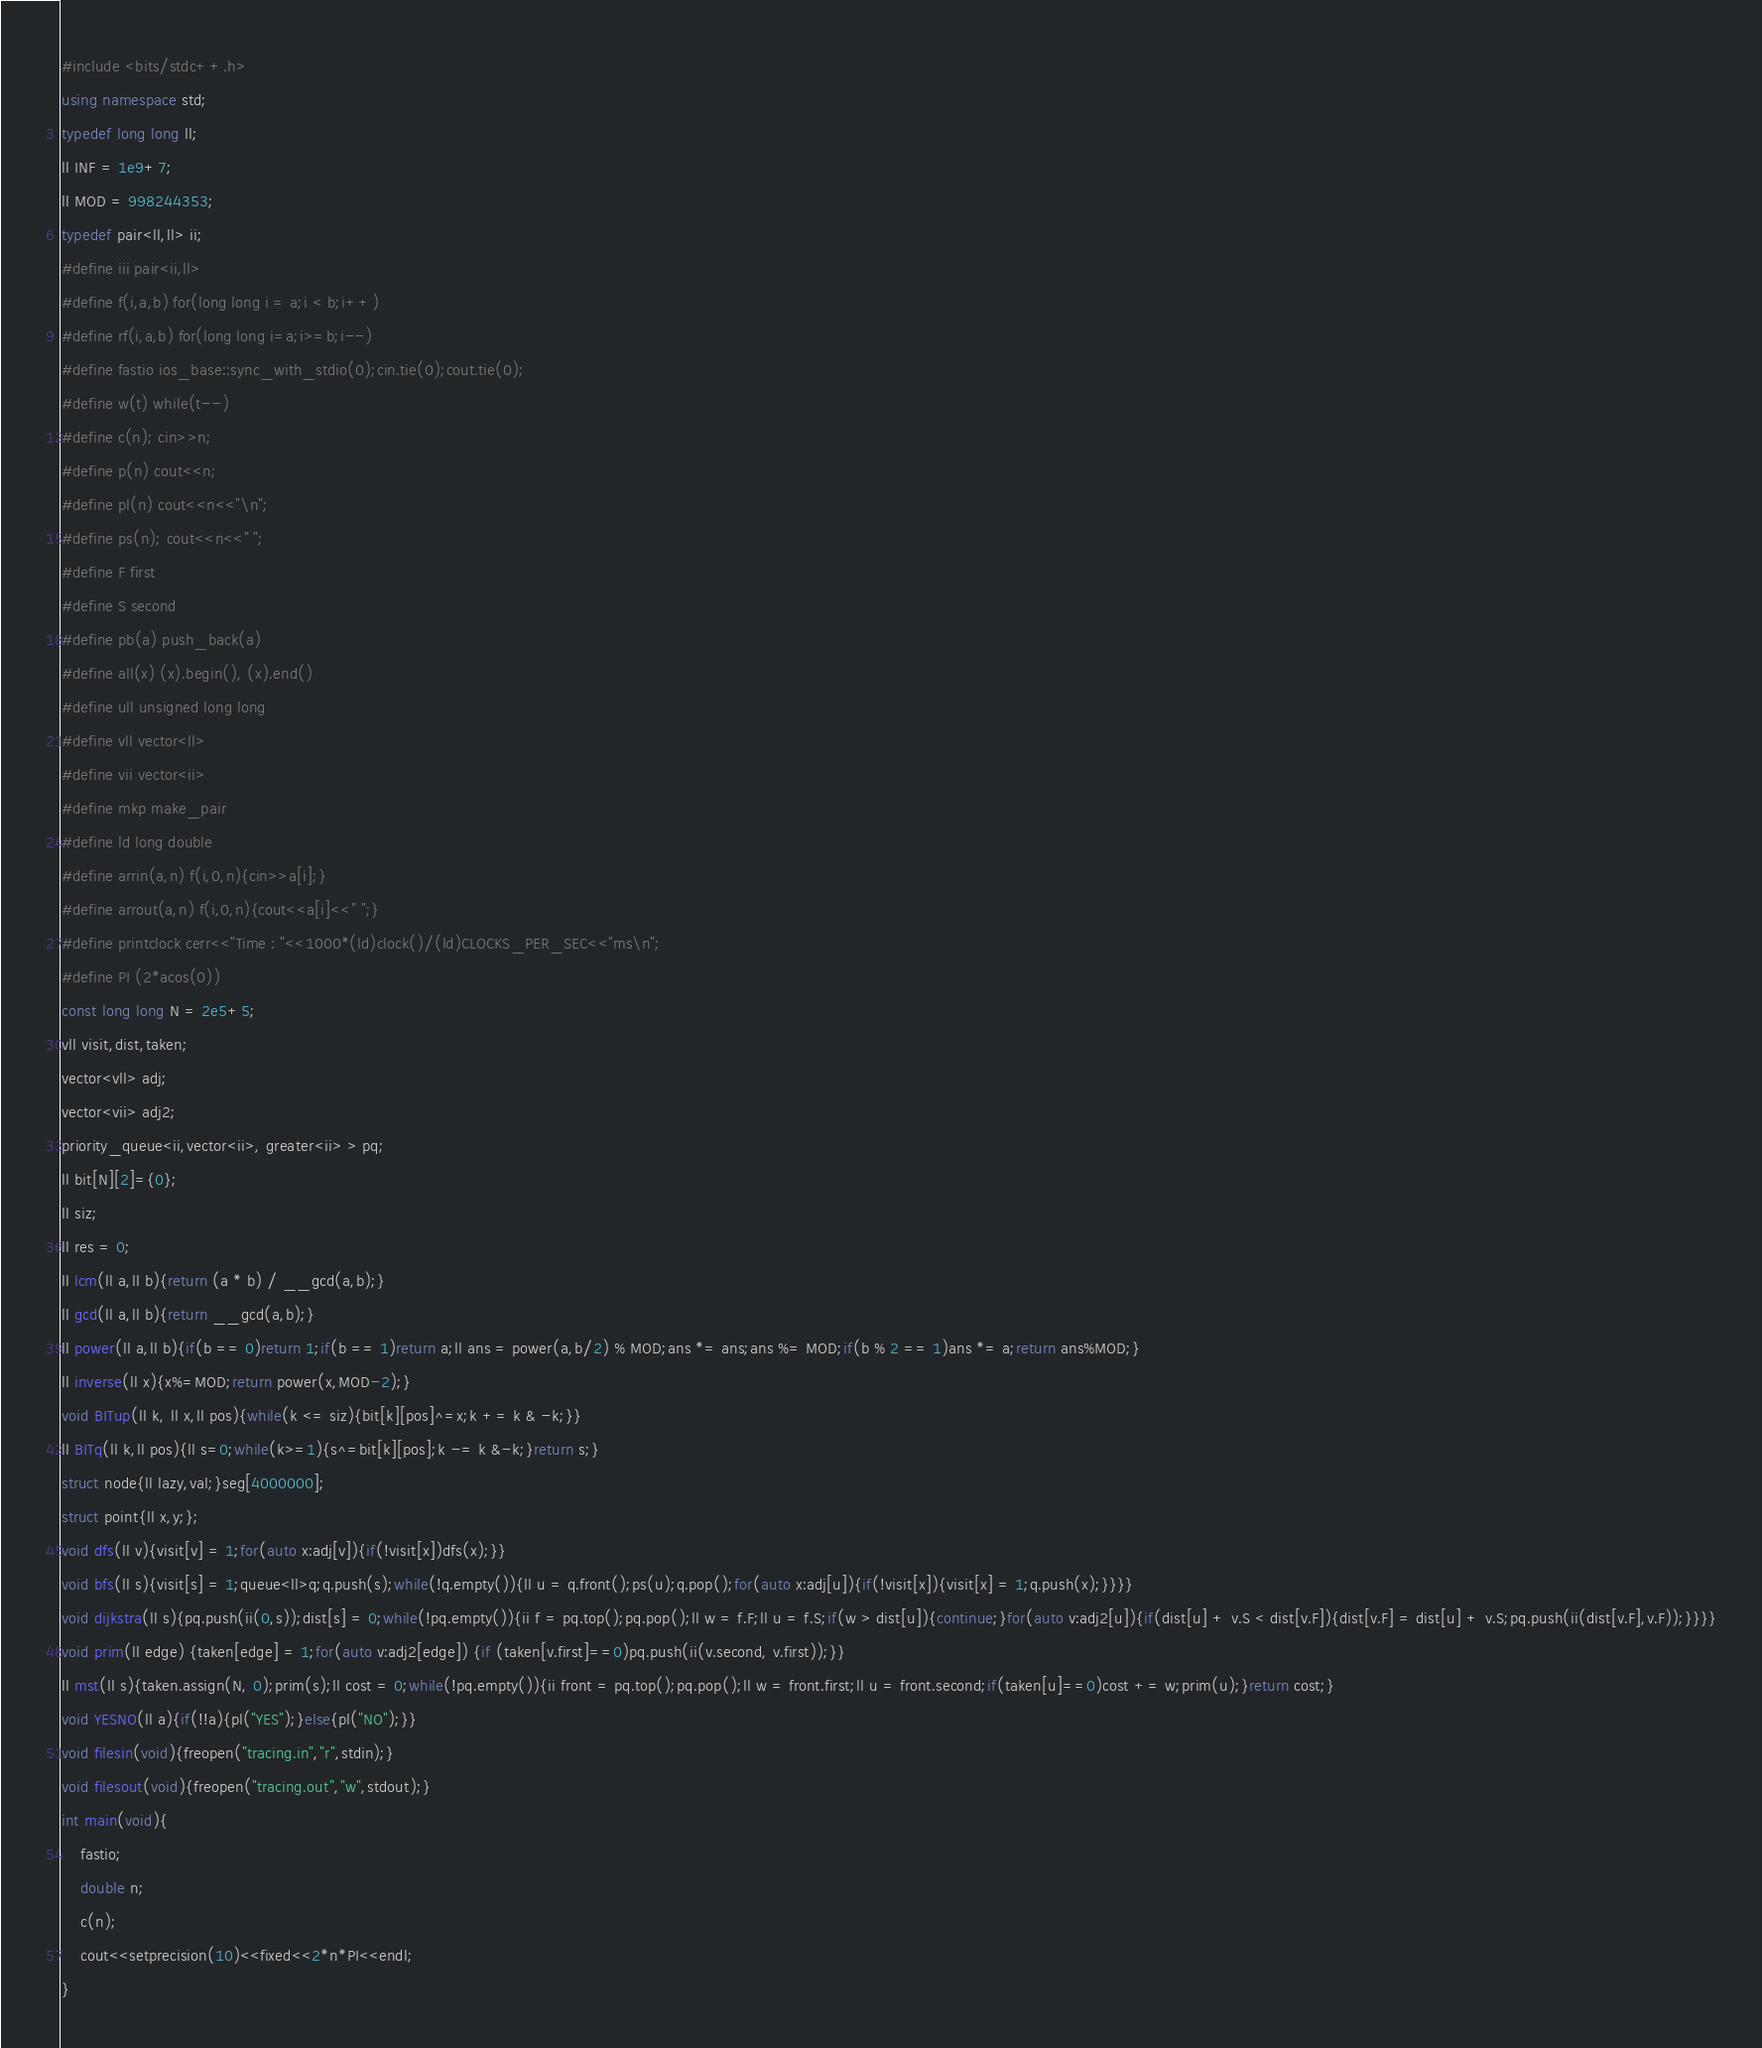Convert code to text. <code><loc_0><loc_0><loc_500><loc_500><_C++_>#include <bits/stdc++.h>
using namespace std;
typedef long long ll;
ll INF = 1e9+7;
ll MOD = 998244353;
typedef pair<ll,ll> ii;
#define iii pair<ii,ll>
#define f(i,a,b) for(long long i = a;i < b;i++)
#define rf(i,a,b) for(long long i=a;i>=b;i--)
#define fastio ios_base::sync_with_stdio(0);cin.tie(0);cout.tie(0);
#define w(t) while(t--)
#define c(n); cin>>n;
#define p(n) cout<<n;
#define pl(n) cout<<n<<"\n";
#define ps(n); cout<<n<<" ";
#define F first
#define S second
#define pb(a) push_back(a)
#define all(x) (x).begin(), (x).end()
#define ull unsigned long long
#define vll vector<ll>
#define vii vector<ii>
#define mkp make_pair
#define ld long double
#define arrin(a,n) f(i,0,n){cin>>a[i];}
#define arrout(a,n) f(i,0,n){cout<<a[i]<<" ";}
#define printclock cerr<<"Time : "<<1000*(ld)clock()/(ld)CLOCKS_PER_SEC<<"ms\n";
#define PI (2*acos(0))
const long long N = 2e5+5;
vll visit,dist,taken;
vector<vll> adj;
vector<vii> adj2;
priority_queue<ii,vector<ii>, greater<ii> > pq;
ll bit[N][2]={0};
ll siz;
ll res = 0;
ll lcm(ll a,ll b){return (a * b) / __gcd(a,b);}
ll gcd(ll a,ll b){return __gcd(a,b);}
ll power(ll a,ll b){if(b == 0)return 1;if(b == 1)return a;ll ans = power(a,b/2) % MOD;ans *= ans;ans %= MOD;if(b % 2 == 1)ans *= a;return ans%MOD;}
ll inverse(ll x){x%=MOD;return power(x,MOD-2);}
void BITup(ll k, ll x,ll pos){while(k <= siz){bit[k][pos]^=x;k += k & -k;}}
ll BITq(ll k,ll pos){ll s=0;while(k>=1){s^=bit[k][pos];k -= k &-k;}return s;}
struct node{ll lazy,val;}seg[4000000];
struct point{ll x,y;};
void dfs(ll v){visit[v] = 1;for(auto x:adj[v]){if(!visit[x])dfs(x);}}
void bfs(ll s){visit[s] = 1;queue<ll>q;q.push(s);while(!q.empty()){ll u = q.front();ps(u);q.pop();for(auto x:adj[u]){if(!visit[x]){visit[x] = 1;q.push(x);}}}}
void dijkstra(ll s){pq.push(ii(0,s));dist[s] = 0;while(!pq.empty()){ii f = pq.top();pq.pop();ll w = f.F;ll u = f.S;if(w > dist[u]){continue;}for(auto v:adj2[u]){if(dist[u] + v.S < dist[v.F]){dist[v.F] = dist[u] + v.S;pq.push(ii(dist[v.F],v.F));}}}}
void prim(ll edge) {taken[edge] = 1;for(auto v:adj2[edge]) {if (taken[v.first]==0)pq.push(ii(v.second, v.first));}}
ll mst(ll s){taken.assign(N, 0);prim(s);ll cost = 0;while(!pq.empty()){ii front = pq.top();pq.pop();ll w = front.first;ll u = front.second;if(taken[u]==0)cost += w;prim(u);}return cost;}
void YESNO(ll a){if(!!a){pl("YES");}else{pl("NO");}}
void filesin(void){freopen("tracing.in","r",stdin);}
void filesout(void){freopen("tracing.out","w",stdout);}
int main(void){
    fastio;
    double n;
    c(n);
    cout<<setprecision(10)<<fixed<<2*n*PI<<endl;
}
</code> 